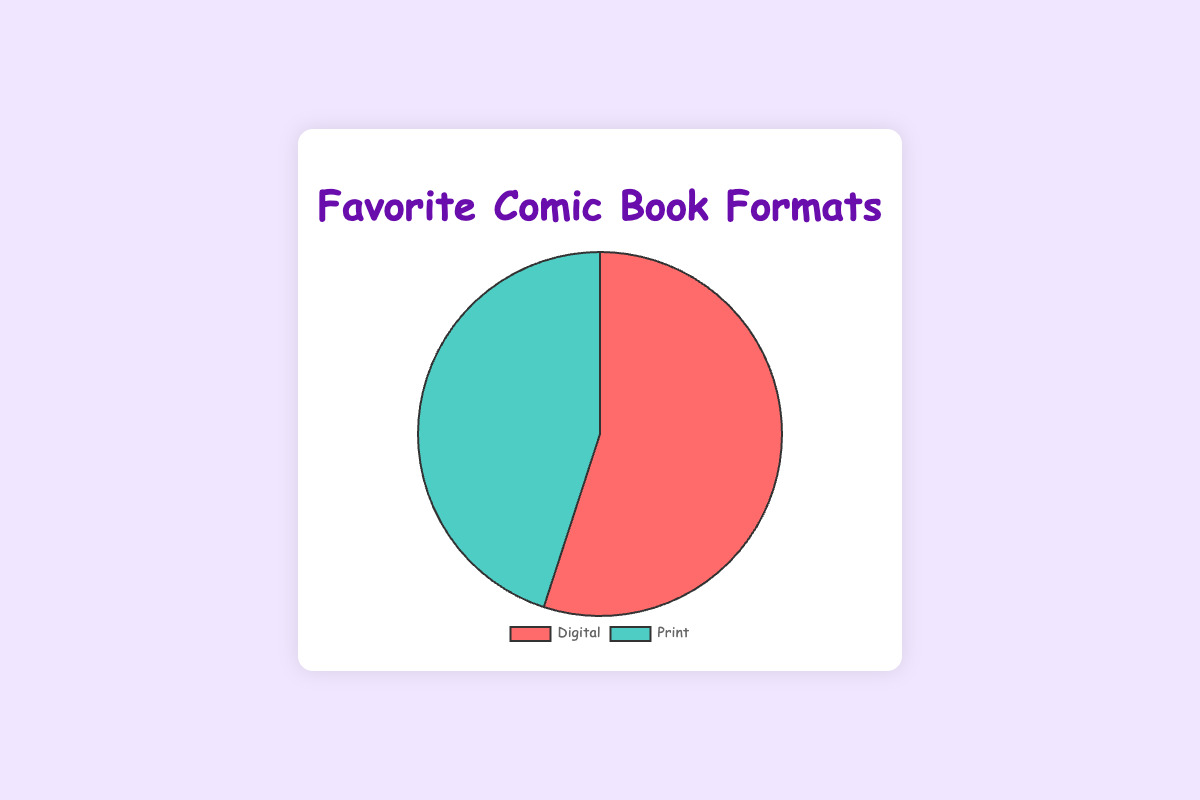What percentage of fans prefer Digital comic book formats? The Pie chart shows that 55% of fans prefer Digital comic book formats, as indicated by the segment labeled 'Digital'.
Answer: 55% Which comic book format has a larger fan base? By comparing the percentages in the Pie chart, it is clear that the 'Digital' format, with 55%, has a larger fan base than the 'Print' format, which has 45%.
Answer: Digital What is the difference in fan base percentages between Digital and Print formats? The Pie chart shows that Digital has 55% and Print has 45%. By calculating the difference: 55% - 45% = 10%.
Answer: 10% What is the most preferred platform for reading Digital comics? According to the data, ComiXology is the most preferred platform for reading Digital comics.
Answer: ComiXology If the total number of fans was 200, how many fans would prefer Print comics? Given the total number of fans is 200 and 45% prefer Print: 200 * 0.45 = 90 fans.
Answer: 90 Which comic book format segment in the Pie chart is represented by a green color? The Pie chart shows that the 'Print' format segment is represented in green.
Answer: Print What are the preferred devices for reading Digital comic books? The data lists Tablet, Smartphone, and eReader as the preferred devices for reading Digital comic books.
Answer: Tablet, Smartphone, eReader Which format is more popular by at least 10%? The Pie chart shows Digital is 55% and Print is 45%. Digital is more popular by exactly 10%.
Answer: Digital What is the combined fan base percentage of both formats? Adding the percentages for Digital (55%) and Print (45%) from the Pie chart gives a combined percentage of 55% + 45% = 100%.
Answer: 100% 